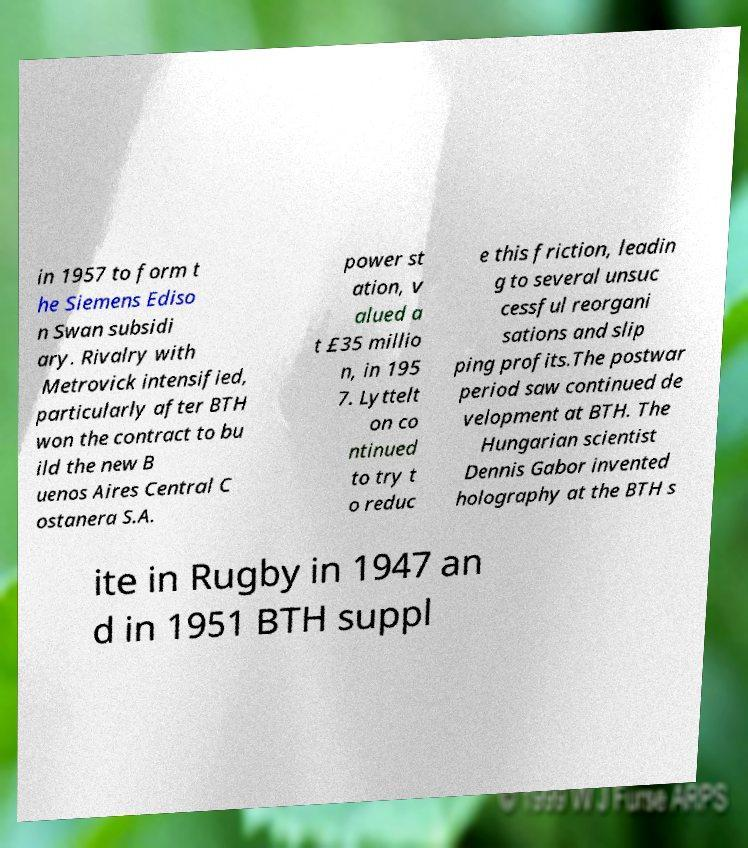What messages or text are displayed in this image? I need them in a readable, typed format. in 1957 to form t he Siemens Ediso n Swan subsidi ary. Rivalry with Metrovick intensified, particularly after BTH won the contract to bu ild the new B uenos Aires Central C ostanera S.A. power st ation, v alued a t £35 millio n, in 195 7. Lyttelt on co ntinued to try t o reduc e this friction, leadin g to several unsuc cessful reorgani sations and slip ping profits.The postwar period saw continued de velopment at BTH. The Hungarian scientist Dennis Gabor invented holography at the BTH s ite in Rugby in 1947 an d in 1951 BTH suppl 